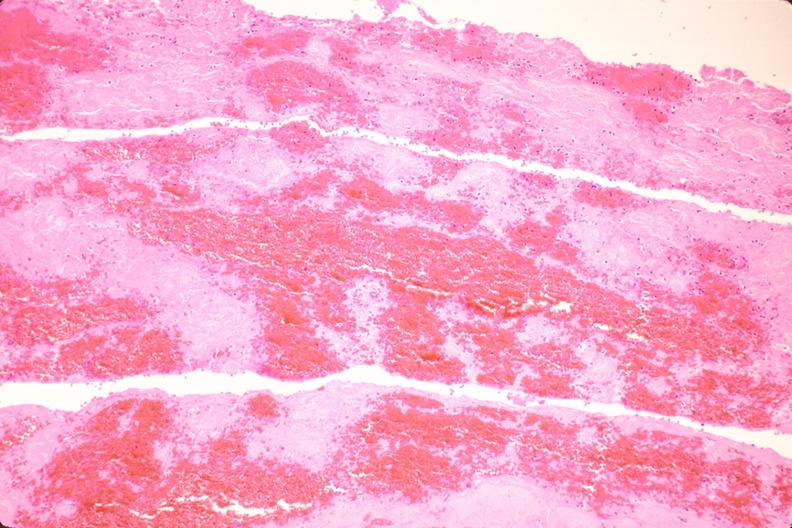s vasculature present?
Answer the question using a single word or phrase. Yes 